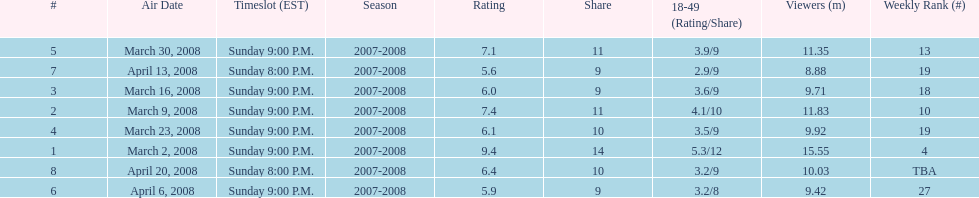How many shows had at least 10 million viewers? 4. 